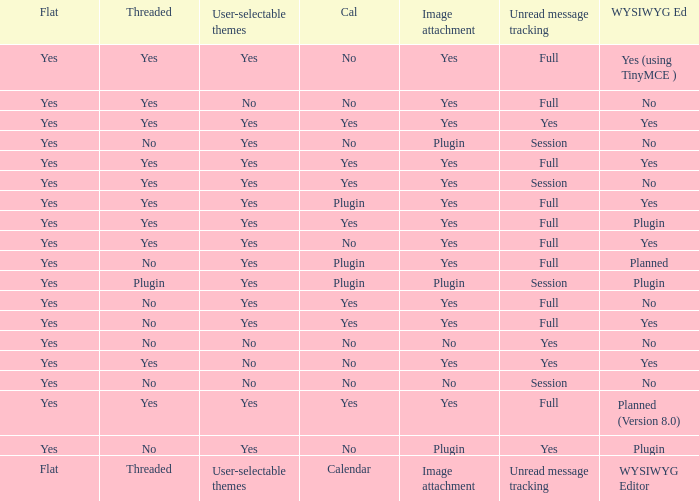Which WYSIWYG Editor has an Image attachment of yes, and a Calendar of plugin? Yes, Planned. 